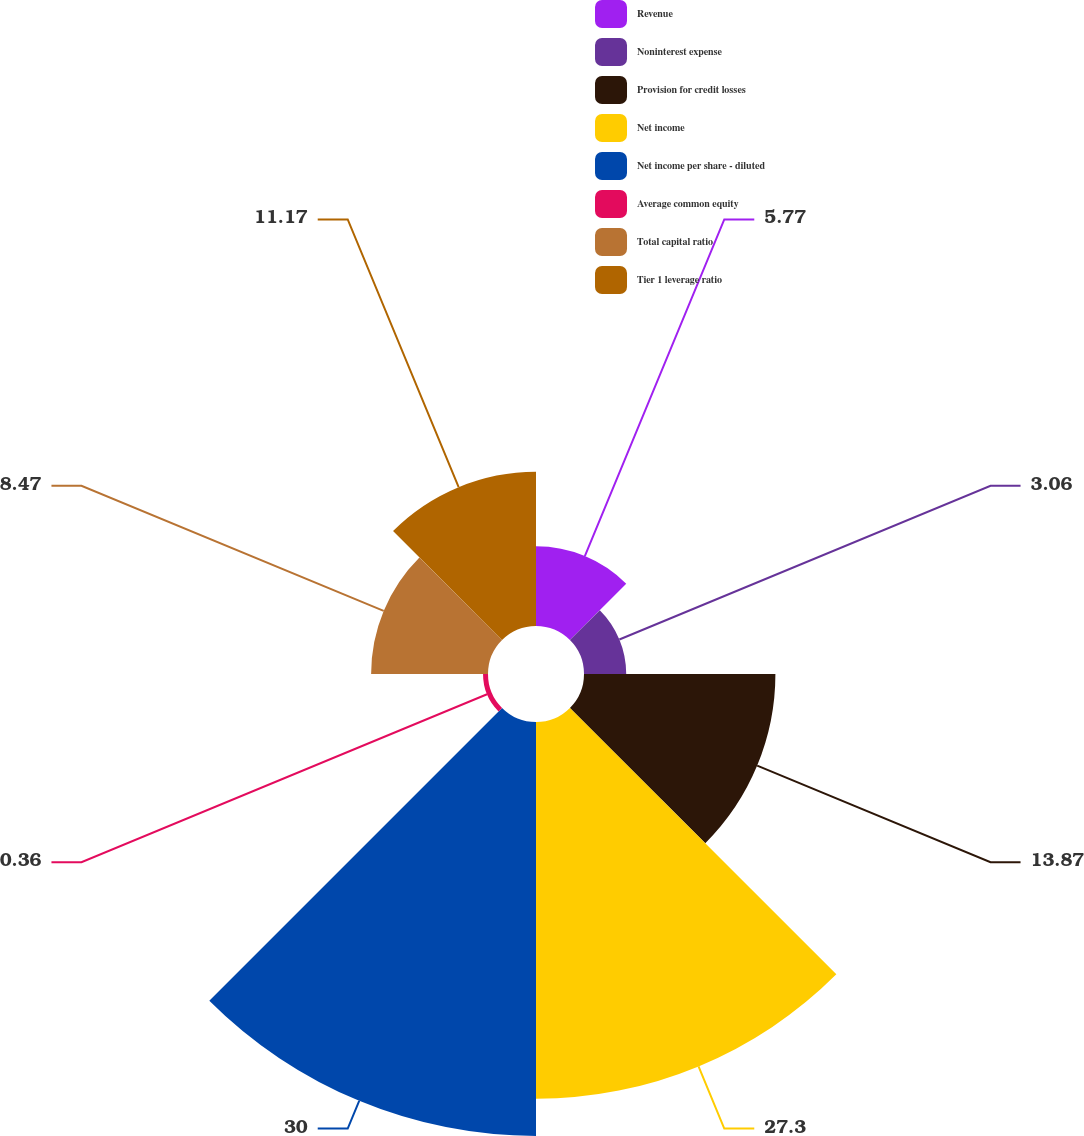<chart> <loc_0><loc_0><loc_500><loc_500><pie_chart><fcel>Revenue<fcel>Noninterest expense<fcel>Provision for credit losses<fcel>Net income<fcel>Net income per share - diluted<fcel>Average common equity<fcel>Total capital ratio<fcel>Tier 1 leverage ratio<nl><fcel>5.77%<fcel>3.06%<fcel>13.87%<fcel>27.3%<fcel>30.0%<fcel>0.36%<fcel>8.47%<fcel>11.17%<nl></chart> 